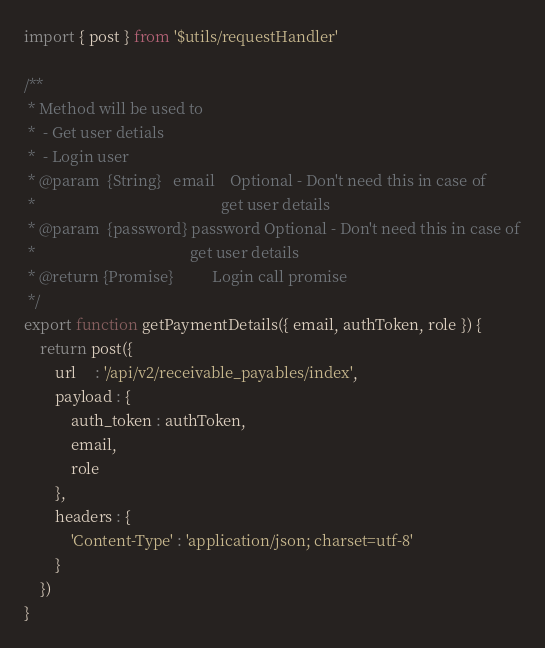Convert code to text. <code><loc_0><loc_0><loc_500><loc_500><_JavaScript_>import { post } from '$utils/requestHandler'

/**
 * Method will be used to
 * 	- Get user detials
 * 	- Login user
 * @param  {String}   email    Optional - Don't need this in case of
 *                             					  get user details
 * @param  {password} password Optional - Don't need this in case of
 *                                        get user details
 * @return {Promise}          Login call promise
 */
export function getPaymentDetails({ email, authToken, role }) {
	return post({
		url     : '/api/v2/receivable_payables/index',
		payload : {
			auth_token : authToken,
			email,
			role
		},
		headers : {
			'Content-Type' : 'application/json; charset=utf-8'
		}
	})
}
</code> 